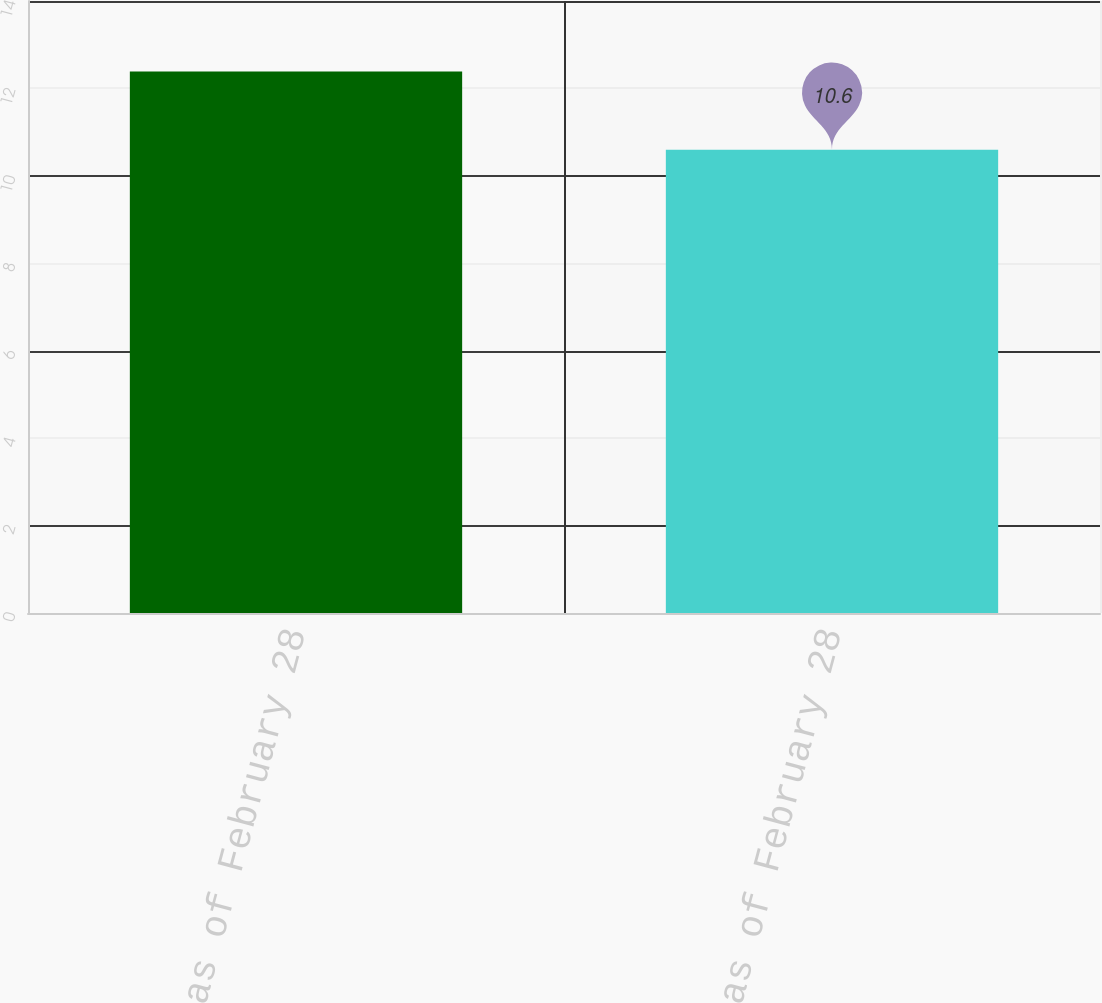Convert chart to OTSL. <chart><loc_0><loc_0><loc_500><loc_500><bar_chart><fcel>Outstanding as of February 28<fcel>Exercisable as of February 28<nl><fcel>12.39<fcel>10.6<nl></chart> 